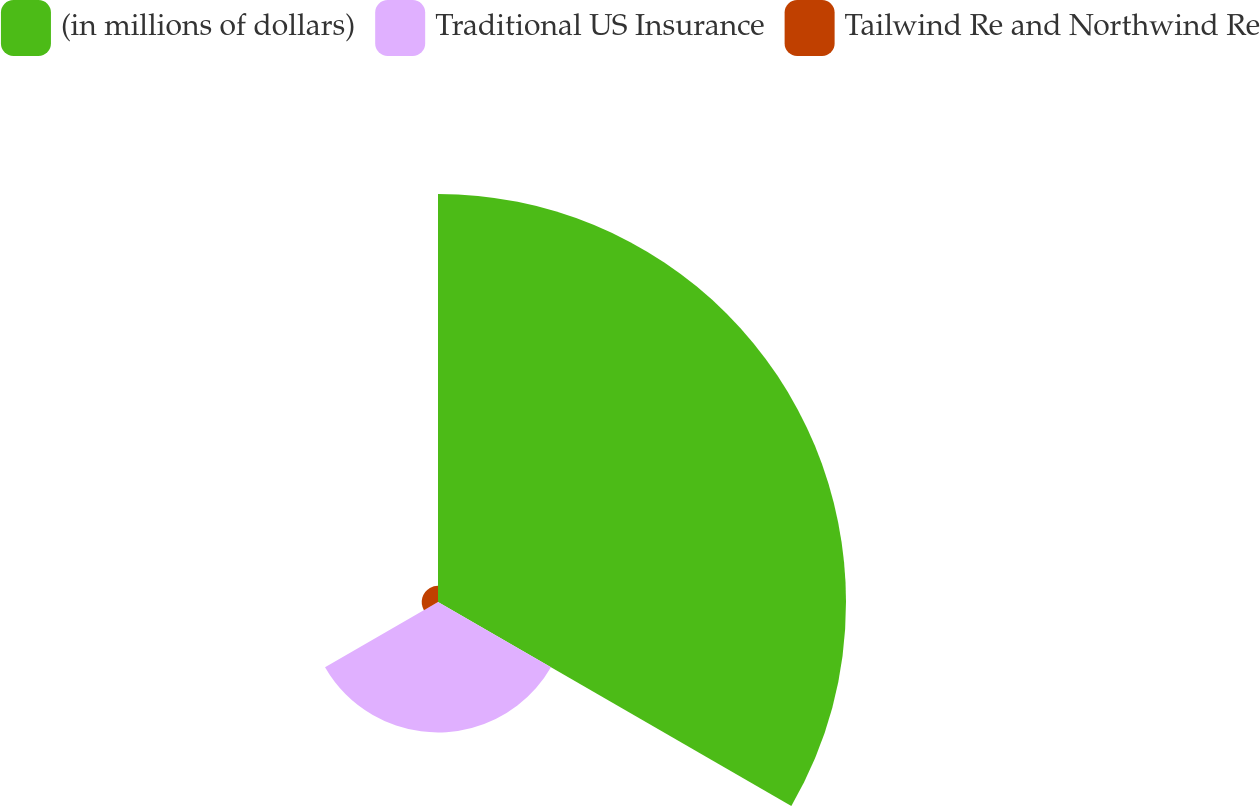Convert chart. <chart><loc_0><loc_0><loc_500><loc_500><pie_chart><fcel>(in millions of dollars)<fcel>Traditional US Insurance<fcel>Tailwind Re and Northwind Re<nl><fcel>73.56%<fcel>23.52%<fcel>2.93%<nl></chart> 